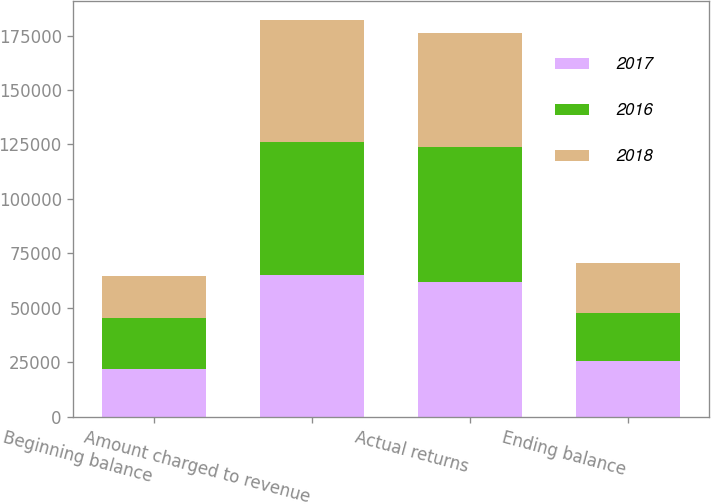<chart> <loc_0><loc_0><loc_500><loc_500><stacked_bar_chart><ecel><fcel>Beginning balance<fcel>Amount charged to revenue<fcel>Actual returns<fcel>Ending balance<nl><fcel>2017<fcel>22006<fcel>65241<fcel>61822<fcel>25425<nl><fcel>2016<fcel>23096<fcel>61031<fcel>62121<fcel>22006<nl><fcel>2018<fcel>19446<fcel>55739<fcel>52089<fcel>23096<nl></chart> 